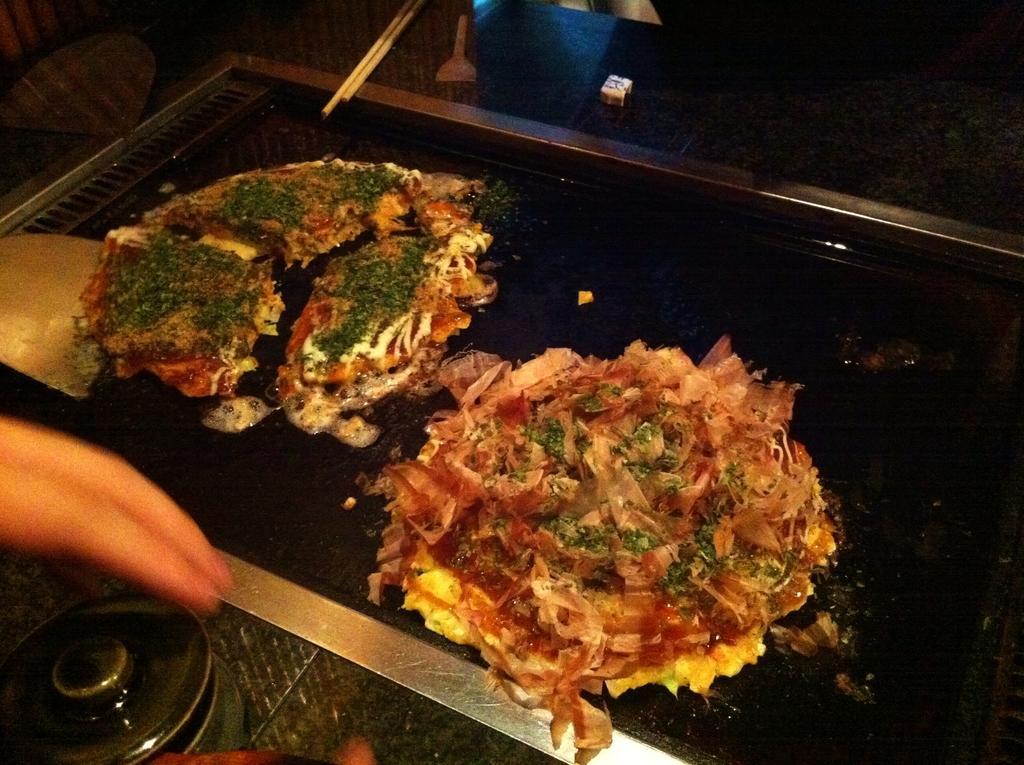Can you describe this image briefly? In this image, I can see the food items, which are on the induction stove. At the top of the image, I think these are the chopsticks. On the left side of the image, I can see a person's fingers. This looks like a jar with a lid. 